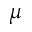<formula> <loc_0><loc_0><loc_500><loc_500>\mu</formula> 